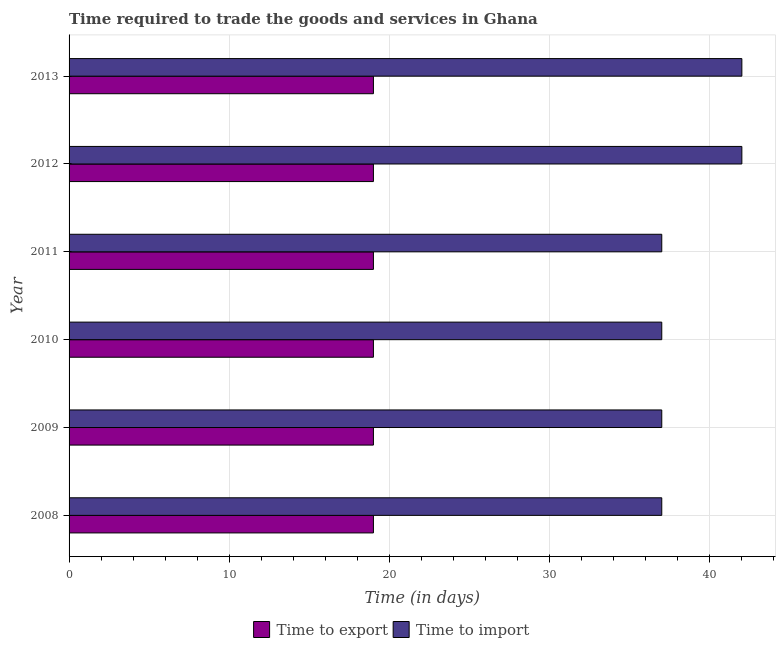Are the number of bars per tick equal to the number of legend labels?
Ensure brevity in your answer.  Yes. Are the number of bars on each tick of the Y-axis equal?
Offer a very short reply. Yes. How many bars are there on the 5th tick from the top?
Offer a very short reply. 2. What is the label of the 1st group of bars from the top?
Your response must be concise. 2013. In how many cases, is the number of bars for a given year not equal to the number of legend labels?
Keep it short and to the point. 0. What is the time to export in 2009?
Keep it short and to the point. 19. Across all years, what is the maximum time to import?
Offer a very short reply. 42. Across all years, what is the minimum time to import?
Provide a succinct answer. 37. In which year was the time to import maximum?
Offer a very short reply. 2012. In which year was the time to import minimum?
Your response must be concise. 2008. What is the total time to export in the graph?
Your answer should be very brief. 114. What is the difference between the time to import in 2008 and that in 2011?
Make the answer very short. 0. What is the difference between the time to export in 2009 and the time to import in 2013?
Offer a very short reply. -23. What is the average time to export per year?
Your response must be concise. 19. In the year 2009, what is the difference between the time to export and time to import?
Your answer should be very brief. -18. What is the ratio of the time to export in 2011 to that in 2013?
Provide a short and direct response. 1. Is the time to export in 2008 less than that in 2011?
Ensure brevity in your answer.  No. What is the difference between the highest and the lowest time to export?
Your response must be concise. 0. In how many years, is the time to export greater than the average time to export taken over all years?
Offer a very short reply. 0. Is the sum of the time to export in 2010 and 2012 greater than the maximum time to import across all years?
Keep it short and to the point. No. What does the 2nd bar from the top in 2011 represents?
Offer a very short reply. Time to export. What does the 1st bar from the bottom in 2010 represents?
Make the answer very short. Time to export. How many bars are there?
Make the answer very short. 12. Are all the bars in the graph horizontal?
Offer a very short reply. Yes. Does the graph contain any zero values?
Your answer should be compact. No. How are the legend labels stacked?
Give a very brief answer. Horizontal. What is the title of the graph?
Provide a short and direct response. Time required to trade the goods and services in Ghana. Does "Crop" appear as one of the legend labels in the graph?
Give a very brief answer. No. What is the label or title of the X-axis?
Ensure brevity in your answer.  Time (in days). What is the label or title of the Y-axis?
Your answer should be compact. Year. What is the Time (in days) of Time to import in 2008?
Your answer should be compact. 37. What is the Time (in days) in Time to export in 2009?
Make the answer very short. 19. What is the Time (in days) of Time to import in 2009?
Give a very brief answer. 37. What is the Time (in days) in Time to import in 2010?
Keep it short and to the point. 37. What is the Time (in days) in Time to export in 2012?
Keep it short and to the point. 19. What is the Time (in days) of Time to import in 2012?
Provide a short and direct response. 42. What is the total Time (in days) in Time to export in the graph?
Your response must be concise. 114. What is the total Time (in days) of Time to import in the graph?
Offer a terse response. 232. What is the difference between the Time (in days) in Time to export in 2008 and that in 2009?
Keep it short and to the point. 0. What is the difference between the Time (in days) in Time to import in 2008 and that in 2009?
Your response must be concise. 0. What is the difference between the Time (in days) in Time to export in 2008 and that in 2010?
Your response must be concise. 0. What is the difference between the Time (in days) of Time to export in 2008 and that in 2011?
Offer a terse response. 0. What is the difference between the Time (in days) of Time to import in 2008 and that in 2012?
Give a very brief answer. -5. What is the difference between the Time (in days) of Time to export in 2009 and that in 2010?
Ensure brevity in your answer.  0. What is the difference between the Time (in days) of Time to export in 2009 and that in 2011?
Make the answer very short. 0. What is the difference between the Time (in days) in Time to export in 2009 and that in 2012?
Give a very brief answer. 0. What is the difference between the Time (in days) of Time to export in 2009 and that in 2013?
Your answer should be compact. 0. What is the difference between the Time (in days) of Time to export in 2010 and that in 2012?
Offer a terse response. 0. What is the difference between the Time (in days) of Time to export in 2011 and that in 2012?
Keep it short and to the point. 0. What is the difference between the Time (in days) of Time to export in 2011 and that in 2013?
Your answer should be compact. 0. What is the difference between the Time (in days) in Time to export in 2008 and the Time (in days) in Time to import in 2009?
Your answer should be compact. -18. What is the difference between the Time (in days) of Time to export in 2008 and the Time (in days) of Time to import in 2010?
Keep it short and to the point. -18. What is the difference between the Time (in days) in Time to export in 2008 and the Time (in days) in Time to import in 2013?
Make the answer very short. -23. What is the difference between the Time (in days) in Time to export in 2009 and the Time (in days) in Time to import in 2010?
Make the answer very short. -18. What is the difference between the Time (in days) in Time to export in 2009 and the Time (in days) in Time to import in 2012?
Your response must be concise. -23. What is the difference between the Time (in days) of Time to export in 2009 and the Time (in days) of Time to import in 2013?
Your answer should be very brief. -23. What is the difference between the Time (in days) in Time to export in 2010 and the Time (in days) in Time to import in 2011?
Keep it short and to the point. -18. What is the difference between the Time (in days) in Time to export in 2012 and the Time (in days) in Time to import in 2013?
Your response must be concise. -23. What is the average Time (in days) in Time to export per year?
Provide a short and direct response. 19. What is the average Time (in days) in Time to import per year?
Make the answer very short. 38.67. In the year 2010, what is the difference between the Time (in days) of Time to export and Time (in days) of Time to import?
Provide a succinct answer. -18. In the year 2011, what is the difference between the Time (in days) of Time to export and Time (in days) of Time to import?
Offer a terse response. -18. What is the ratio of the Time (in days) of Time to export in 2008 to that in 2009?
Provide a short and direct response. 1. What is the ratio of the Time (in days) in Time to export in 2008 to that in 2010?
Your answer should be compact. 1. What is the ratio of the Time (in days) of Time to import in 2008 to that in 2011?
Ensure brevity in your answer.  1. What is the ratio of the Time (in days) in Time to import in 2008 to that in 2012?
Your answer should be very brief. 0.88. What is the ratio of the Time (in days) of Time to import in 2008 to that in 2013?
Provide a succinct answer. 0.88. What is the ratio of the Time (in days) of Time to export in 2009 to that in 2011?
Make the answer very short. 1. What is the ratio of the Time (in days) of Time to import in 2009 to that in 2011?
Provide a succinct answer. 1. What is the ratio of the Time (in days) in Time to import in 2009 to that in 2012?
Give a very brief answer. 0.88. What is the ratio of the Time (in days) in Time to export in 2009 to that in 2013?
Provide a short and direct response. 1. What is the ratio of the Time (in days) in Time to import in 2009 to that in 2013?
Your answer should be compact. 0.88. What is the ratio of the Time (in days) in Time to export in 2010 to that in 2012?
Offer a very short reply. 1. What is the ratio of the Time (in days) of Time to import in 2010 to that in 2012?
Give a very brief answer. 0.88. What is the ratio of the Time (in days) in Time to export in 2010 to that in 2013?
Make the answer very short. 1. What is the ratio of the Time (in days) of Time to import in 2010 to that in 2013?
Give a very brief answer. 0.88. What is the ratio of the Time (in days) in Time to export in 2011 to that in 2012?
Provide a succinct answer. 1. What is the ratio of the Time (in days) in Time to import in 2011 to that in 2012?
Provide a succinct answer. 0.88. What is the ratio of the Time (in days) of Time to export in 2011 to that in 2013?
Make the answer very short. 1. What is the ratio of the Time (in days) in Time to import in 2011 to that in 2013?
Make the answer very short. 0.88. What is the ratio of the Time (in days) in Time to export in 2012 to that in 2013?
Provide a short and direct response. 1. What is the difference between the highest and the second highest Time (in days) in Time to export?
Your answer should be compact. 0. What is the difference between the highest and the second highest Time (in days) of Time to import?
Provide a succinct answer. 0. What is the difference between the highest and the lowest Time (in days) in Time to import?
Provide a succinct answer. 5. 